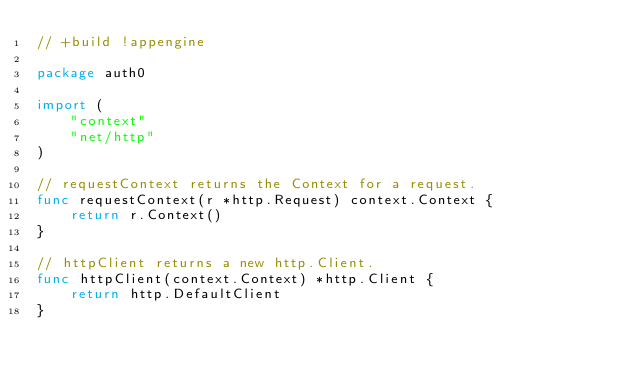<code> <loc_0><loc_0><loc_500><loc_500><_Go_>// +build !appengine

package auth0

import (
	"context"
	"net/http"
)

// requestContext returns the Context for a request.
func requestContext(r *http.Request) context.Context {
	return r.Context()
}

// httpClient returns a new http.Client.
func httpClient(context.Context) *http.Client {
	return http.DefaultClient
}
</code> 